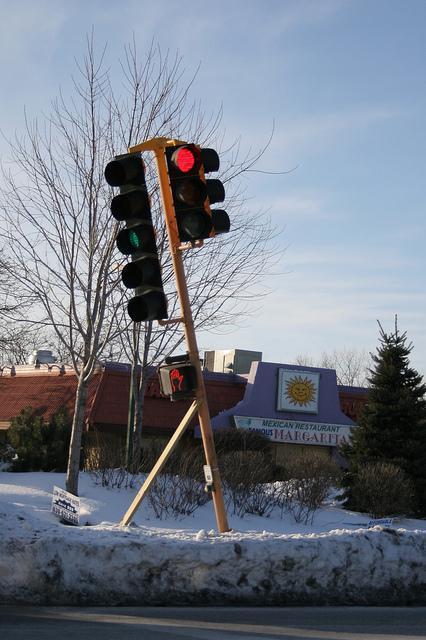How many traffic lights are visible?
Give a very brief answer. 2. 